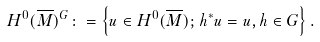Convert formula to latex. <formula><loc_0><loc_0><loc_500><loc_500>H ^ { 0 } ( \overline { M } ) ^ { G } \colon = \left \{ u \in H ^ { 0 } ( \overline { M } ) ; \, h ^ { * } u = u , h \in G \right \} .</formula> 